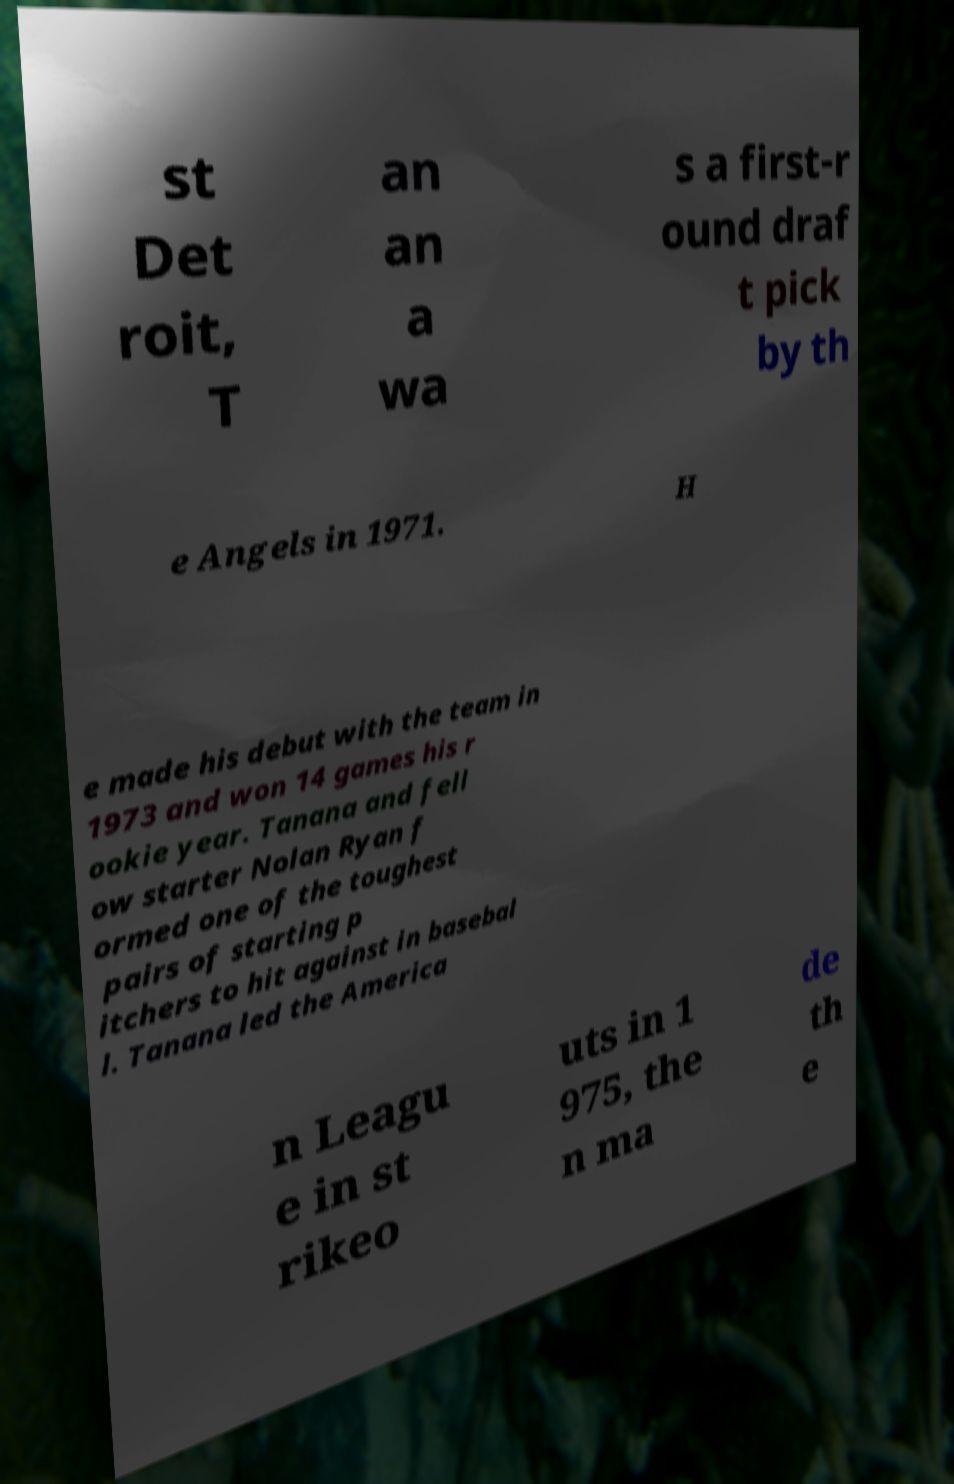For documentation purposes, I need the text within this image transcribed. Could you provide that? st Det roit, T an an a wa s a first-r ound draf t pick by th e Angels in 1971. H e made his debut with the team in 1973 and won 14 games his r ookie year. Tanana and fell ow starter Nolan Ryan f ormed one of the toughest pairs of starting p itchers to hit against in basebal l. Tanana led the America n Leagu e in st rikeo uts in 1 975, the n ma de th e 